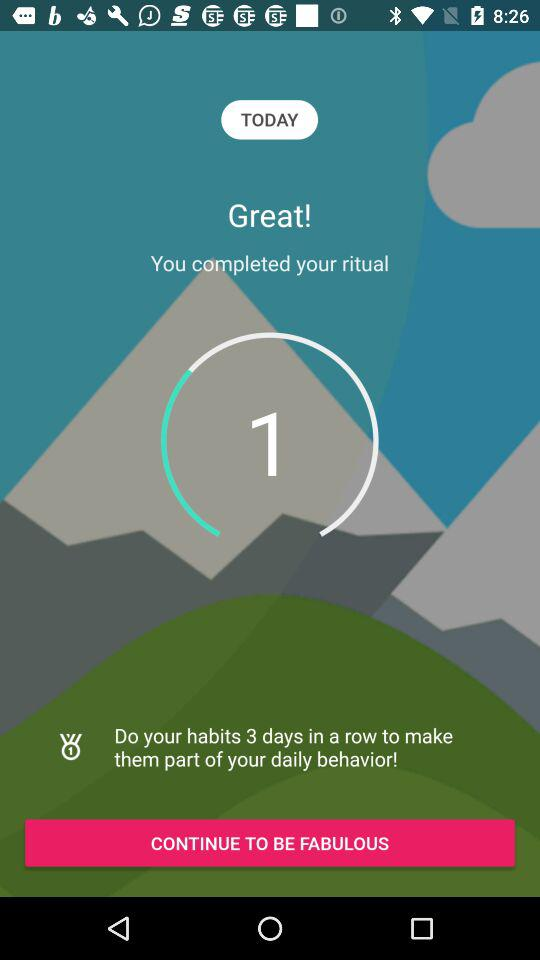How many days have I completed my ritual in a row?
Answer the question using a single word or phrase. 1 